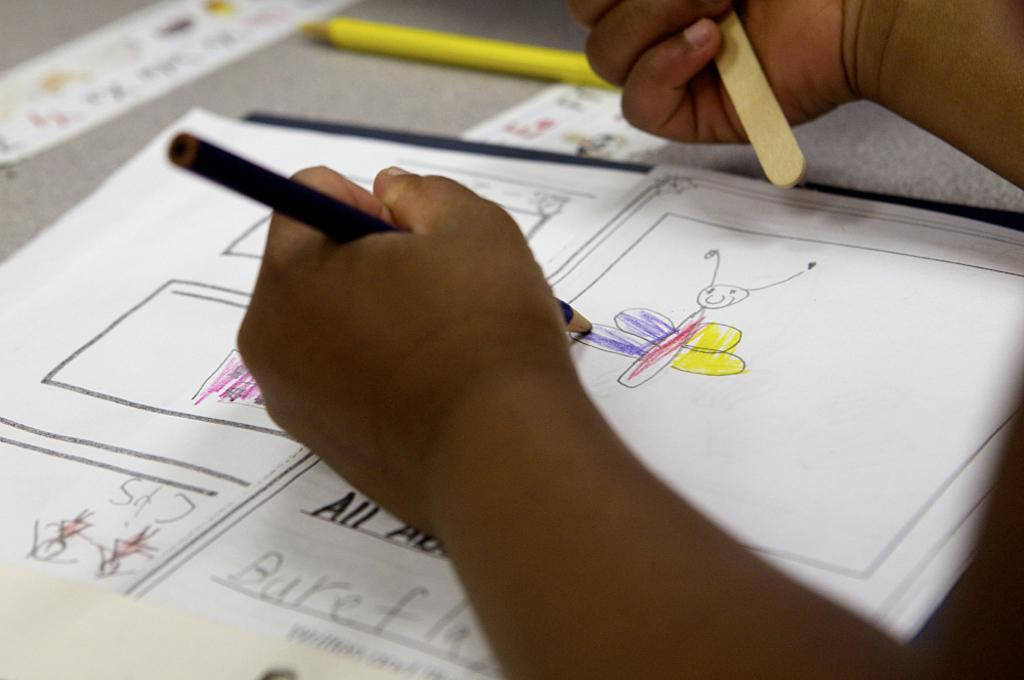<image>
Describe the image concisely. Person drawing a bee and the word "All" under his hand. 